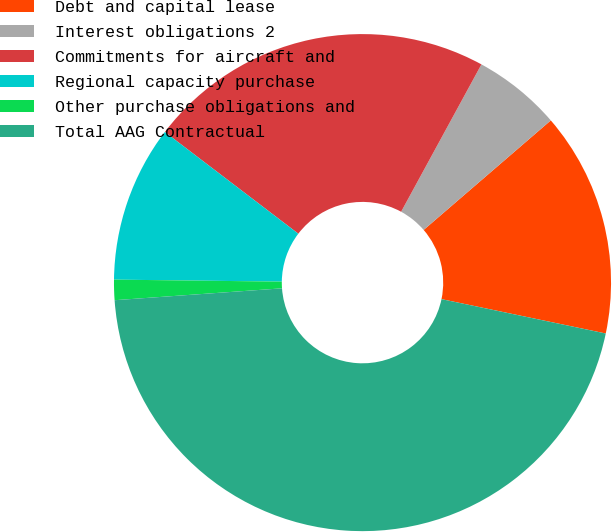Convert chart to OTSL. <chart><loc_0><loc_0><loc_500><loc_500><pie_chart><fcel>Debt and capital lease<fcel>Interest obligations 2<fcel>Commitments for aircraft and<fcel>Regional capacity purchase<fcel>Other purchase obligations and<fcel>Total AAG Contractual<nl><fcel>14.6%<fcel>5.74%<fcel>22.58%<fcel>10.17%<fcel>1.32%<fcel>45.59%<nl></chart> 